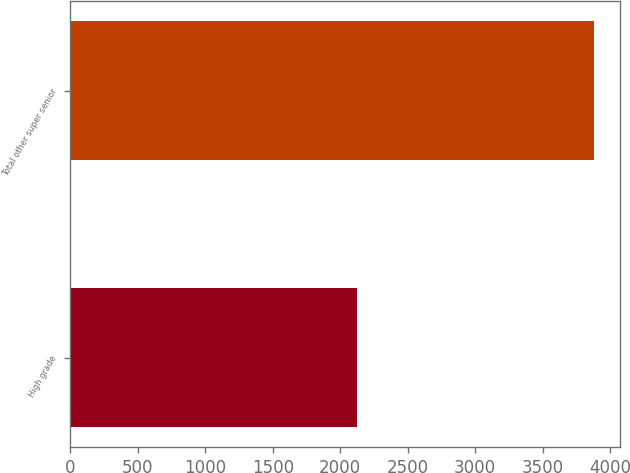<chart> <loc_0><loc_0><loc_500><loc_500><bar_chart><fcel>High grade<fcel>Total other super senior<nl><fcel>2125<fcel>3879<nl></chart> 